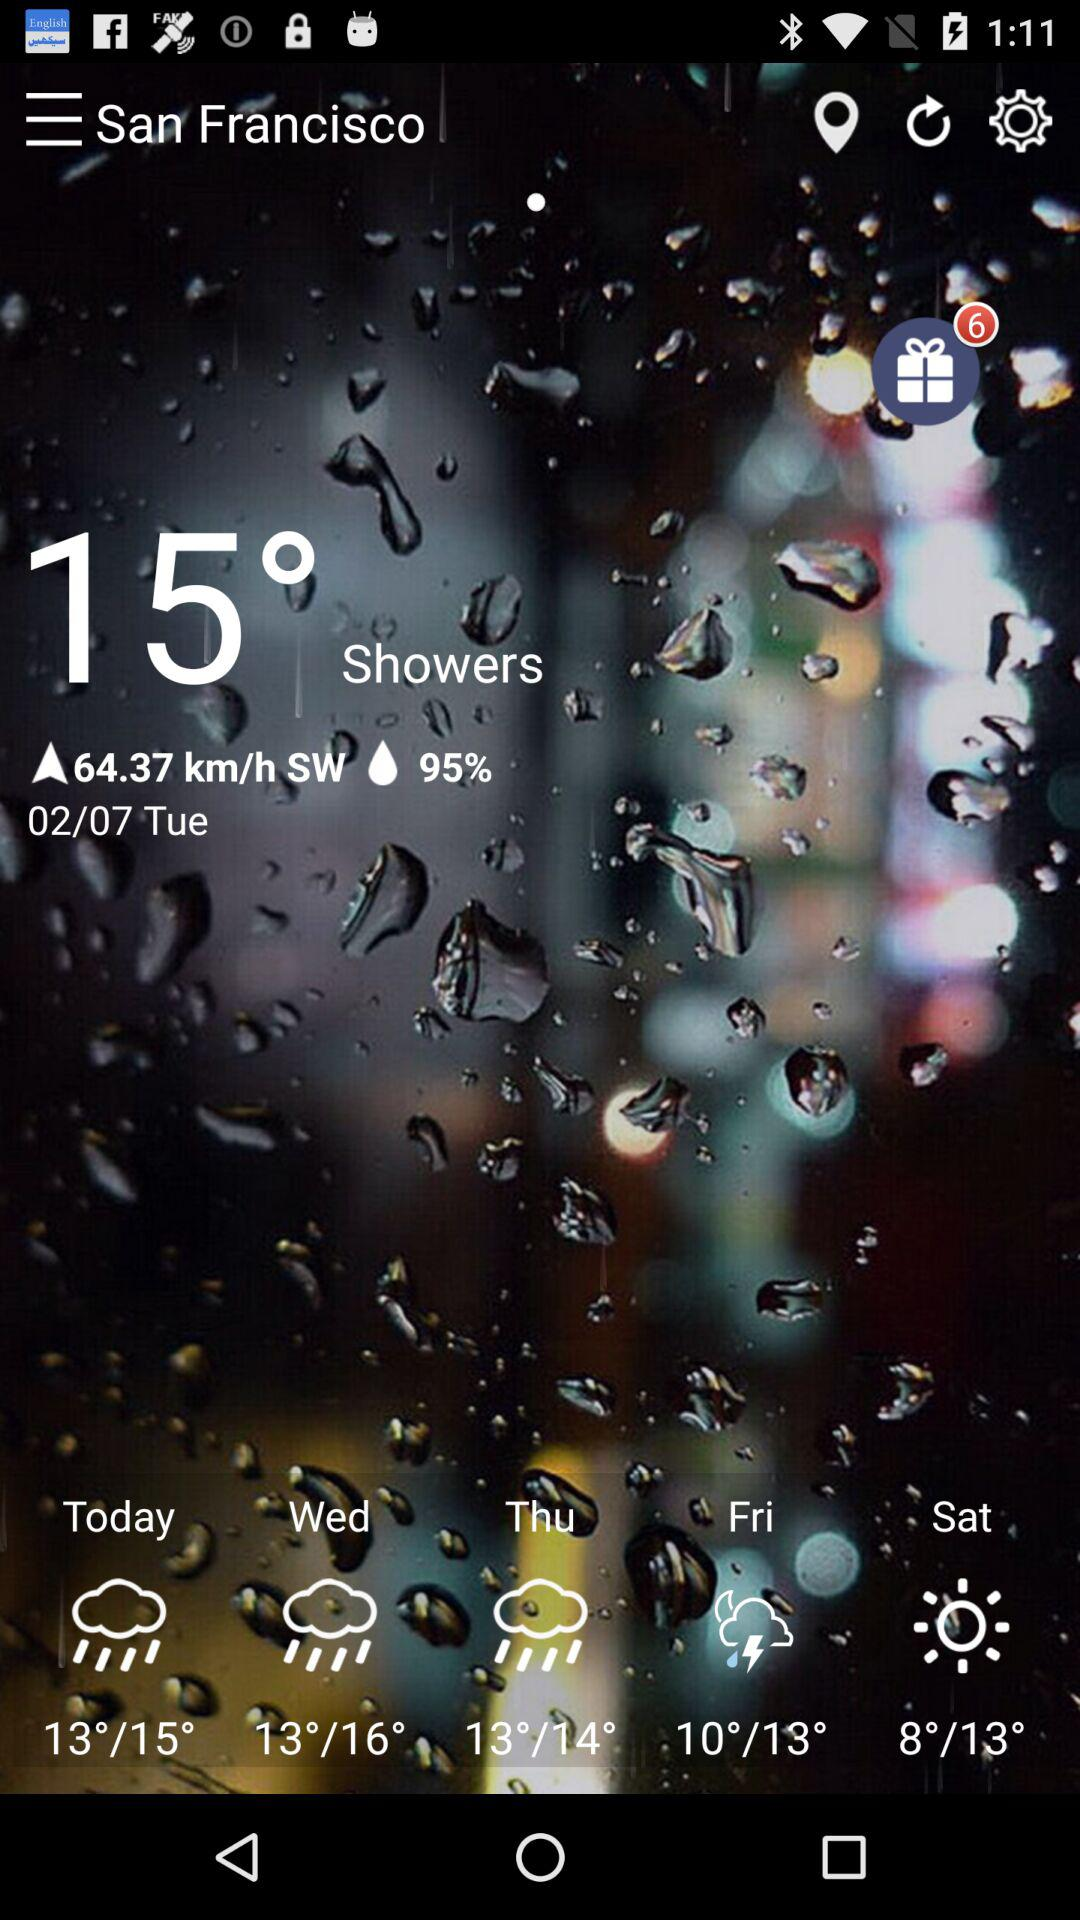What is the location? The location is San Francisco. 